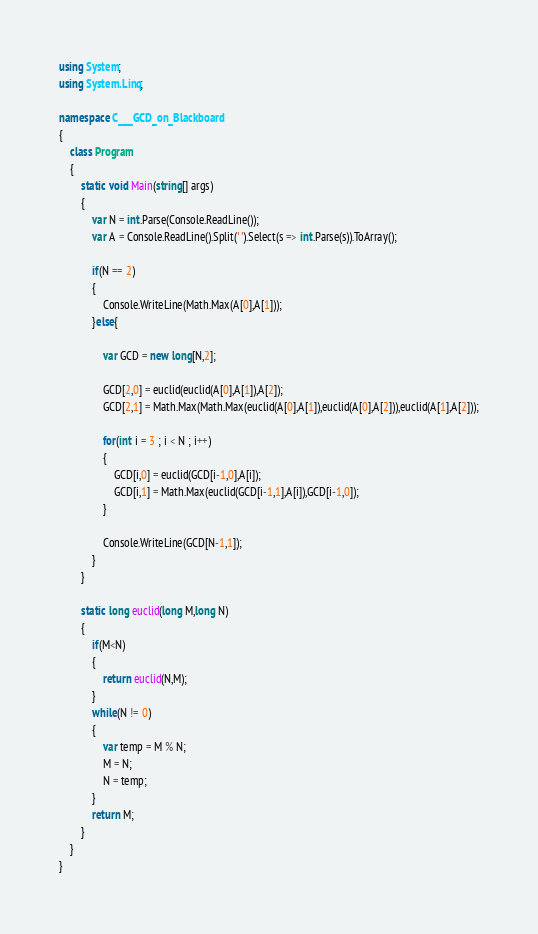<code> <loc_0><loc_0><loc_500><loc_500><_C#_>using System;
using System.Linq;

namespace C___GCD_on_Blackboard
{
    class Program
    {
        static void Main(string[] args)
        {
            var N = int.Parse(Console.ReadLine());
            var A = Console.ReadLine().Split(' ').Select(s => int.Parse(s)).ToArray();

            if(N == 2)
            {
                Console.WriteLine(Math.Max(A[0],A[1]));
            }else{

                var GCD = new long[N,2];
                
                GCD[2,0] = euclid(euclid(A[0],A[1]),A[2]);
                GCD[2,1] = Math.Max(Math.Max(euclid(A[0],A[1]),euclid(A[0],A[2])),euclid(A[1],A[2]));

                for(int i = 3 ; i < N ; i++)
                {
                    GCD[i,0] = euclid(GCD[i-1,0],A[i]);
                    GCD[i,1] = Math.Max(euclid(GCD[i-1,1],A[i]),GCD[i-1,0]);
                }

                Console.WriteLine(GCD[N-1,1]);
            }
        }
        
        static long euclid(long M,long N)
        {
            if(M<N)
            {
                return euclid(N,M);
            }
            while(N != 0)
            {
                var temp = M % N;
                M = N;
                N = temp;
            }
            return M;
        }
    }
}
</code> 